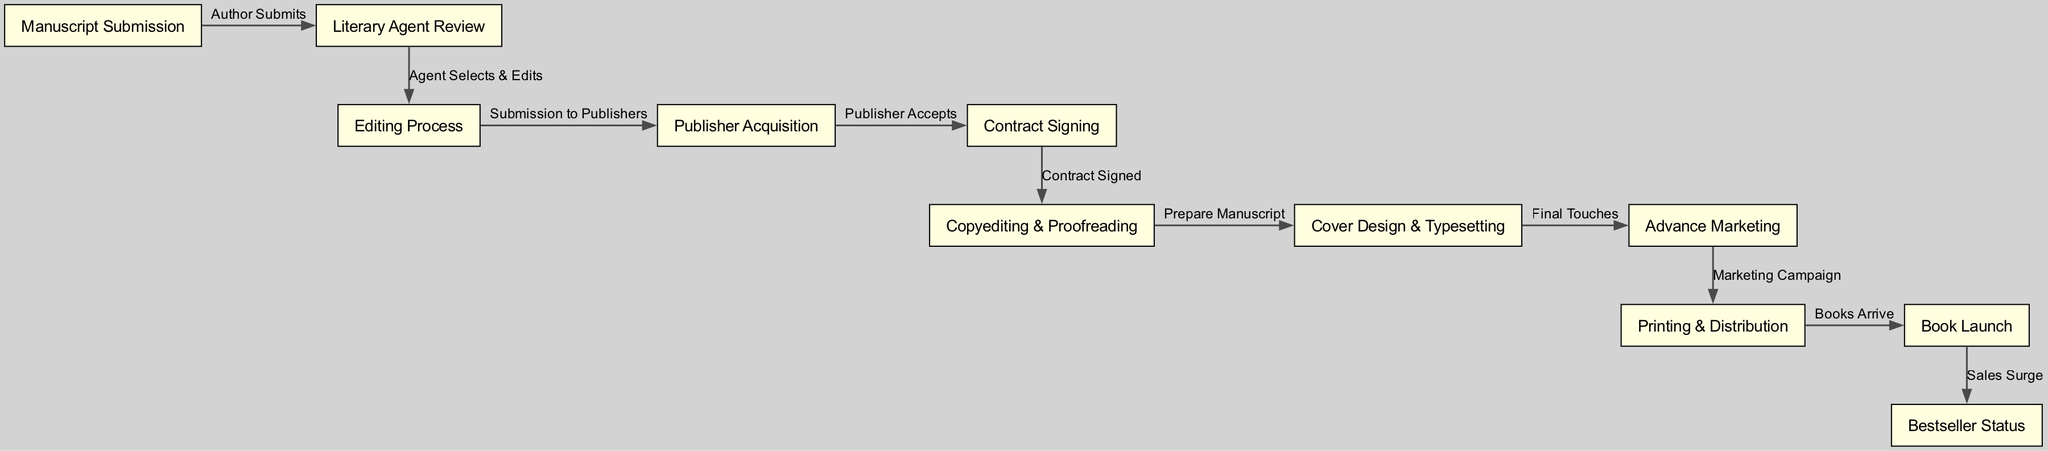What is the first node in the life cycle of a book? The first node in the diagram is "Manuscript Submission", representing the starting point of the book's journey.
Answer: Manuscript Submission How many nodes are there in the diagram? By counting the unique entries in the nodes list of the diagram, we find a total of 11 distinct nodes representing various stages.
Answer: 11 What is the last step in the book's life cycle? The final node, "Bestseller Status", signifies the successful culmination of the book's journey, and it is the last point in the diagram.
Answer: Bestseller Status What action occurs between “Cover Design & Typesetting” and “Advance Marketing”? The edge labeled "Final Touches" indicates that this action takes place between these two stages, signifying completion before moving on to marketing.
Answer: Final Touches What represents the transition from "Book Launch" to "Bestseller Status"? The edge labeled "Sales Surge" signifies the transition from the book launch phase to achieving bestseller status, showing the outcome of successful marketing efforts.
Answer: Sales Surge Which process comes directly after "Contract Signing"? The process that follows "Contract Signing" is "Copyediting & Proofreading", as indicated by the connecting edge.
Answer: Copyediting & Proofreading How many edges are there in the diagram? Counting all the connections between nodes, we determine there are 10 edges linking various stages of the book's life cycle.
Answer: 10 What is the relationship between "Publisher Acquisition" and "Contract Signing"? The connection is represented by the edge labeled "Contract Signed", indicating a relationship where acquiring a publisher leads to signing a contract.
Answer: Contract Signed What step occurs just before “Book Launch”? The step that comes right before “Book Launch” is “Printing & Distribution”, as indicated by the prior edge connecting these two nodes.
Answer: Printing & Distribution 